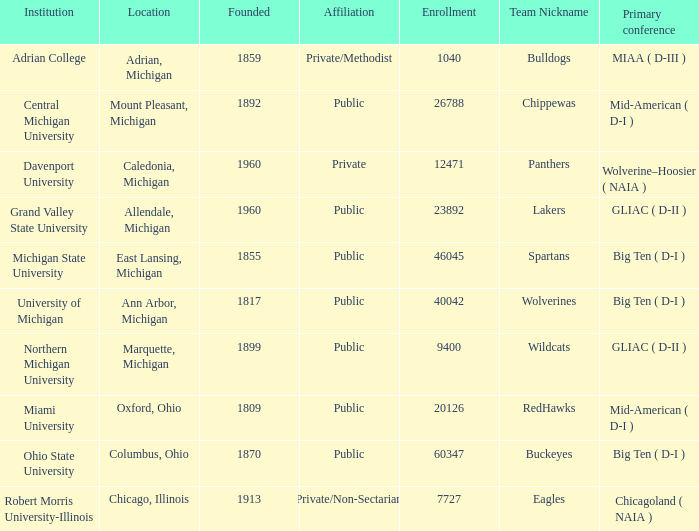How many primary conferences were held in Allendale, Michigan? 1.0. Could you parse the entire table? {'header': ['Institution', 'Location', 'Founded', 'Affiliation', 'Enrollment', 'Team Nickname', 'Primary conference'], 'rows': [['Adrian College', 'Adrian, Michigan', '1859', 'Private/Methodist', '1040', 'Bulldogs', 'MIAA ( D-III )'], ['Central Michigan University', 'Mount Pleasant, Michigan', '1892', 'Public', '26788', 'Chippewas', 'Mid-American ( D-I )'], ['Davenport University', 'Caledonia, Michigan', '1960', 'Private', '12471', 'Panthers', 'Wolverine–Hoosier ( NAIA )'], ['Grand Valley State University', 'Allendale, Michigan', '1960', 'Public', '23892', 'Lakers', 'GLIAC ( D-II )'], ['Michigan State University', 'East Lansing, Michigan', '1855', 'Public', '46045', 'Spartans', 'Big Ten ( D-I )'], ['University of Michigan', 'Ann Arbor, Michigan', '1817', 'Public', '40042', 'Wolverines', 'Big Ten ( D-I )'], ['Northern Michigan University', 'Marquette, Michigan', '1899', 'Public', '9400', 'Wildcats', 'GLIAC ( D-II )'], ['Miami University', 'Oxford, Ohio', '1809', 'Public', '20126', 'RedHawks', 'Mid-American ( D-I )'], ['Ohio State University', 'Columbus, Ohio', '1870', 'Public', '60347', 'Buckeyes', 'Big Ten ( D-I )'], ['Robert Morris University-Illinois', 'Chicago, Illinois', '1913', 'Private/Non-Sectarian', '7727', 'Eagles', 'Chicagoland ( NAIA )']]} 